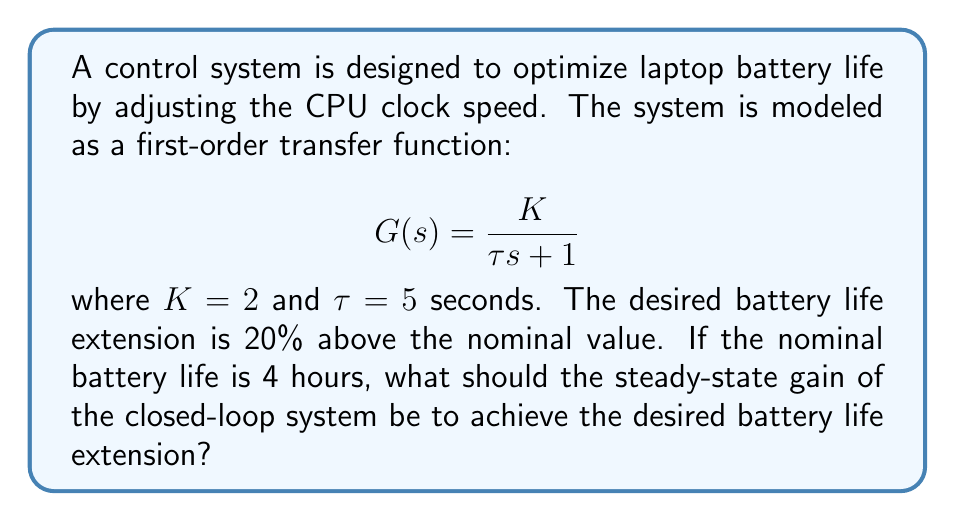Provide a solution to this math problem. To solve this problem, we need to follow these steps:

1. Understand the given information:
   - The system is modeled as a first-order transfer function
   - $K = 2$ (open-loop gain)
   - $\tau = 5$ seconds (time constant)
   - Nominal battery life = 4 hours
   - Desired battery life extension = 20% above nominal

2. Calculate the desired battery life:
   Desired battery life = Nominal battery life × (1 + Extension percentage)
   $$ 4 \text{ hours} \times (1 + 0.20) = 4.8 \text{ hours} $$

3. Determine the required steady-state gain:
   The steady-state gain represents the ratio of the output to the input in the steady state. In this case, it's the ratio of the desired battery life to the nominal battery life.

   Required steady-state gain = Desired battery life ÷ Nominal battery life
   $$ \frac{4.8 \text{ hours}}{4 \text{ hours}} = 1.2 $$

4. For a unity feedback control system, the closed-loop transfer function is:
   $$ T(s) = \frac{G(s)}{1 + G(s)} $$

5. The steady-state gain of the closed-loop system is equal to T(0), which can be calculated as:
   $$ T(0) = \frac{G(0)}{1 + G(0)} = \frac{K}{1 + K} $$

6. Set this equal to the required steady-state gain and solve for K:
   $$ \frac{K}{1 + K} = 1.2 $$
   $$ K = 1.2(1 + K) $$
   $$ K = 1.2 + 1.2K $$
   $$ -0.2K = 1.2 $$
   $$ K = -6 $$

7. The negative gain is not physically realizable in this context, so we need to introduce a controller with gain Kc in series with the plant:
   $$ G_c(s) = K_c $$

8. Now, the new open-loop transfer function is:
   $$ G_{new}(s) = K_c G(s) = \frac{2K_c}{5s + 1} $$

9. Setting the steady-state gain equal to 1.2:
   $$ \frac{2K_c}{1 + 2K_c} = 1.2 $$
   $$ 2K_c = 1.2(1 + 2K_c) $$
   $$ 2K_c = 1.2 + 2.4K_c $$
   $$ -0.4K_c = 1.2 $$
   $$ K_c = -3 $$

10. The negative gain for the controller is also not physically realizable. This means we need to invert the error signal in the feedback loop, which is equivalent to using positive feedback instead of negative feedback.

11. With positive feedback, the closed-loop transfer function becomes:
    $$ T(s) = \frac{G(s)}{1 - G(s)} $$

12. Solving for the required Kc with positive feedback:
    $$ \frac{2K_c}{1 - 2K_c} = 1.2 $$
    $$ 2K_c = 1.2(1 - 2K_c) $$
    $$ 2K_c = 1.2 - 2.4K_c $$
    $$ 4.4K_c = 1.2 $$
    $$ K_c = \frac{1.2}{4.4} = \frac{3}{11} \approx 0.2727 $$

Therefore, the controller gain Kc should be set to 3/11 (approximately 0.2727) with positive feedback to achieve the desired battery life extension.
Answer: The steady-state gain of the closed-loop system should be 1.2, which can be achieved by introducing a controller with gain $K_c = \frac{3}{11} \approx 0.2727$ and using positive feedback. 